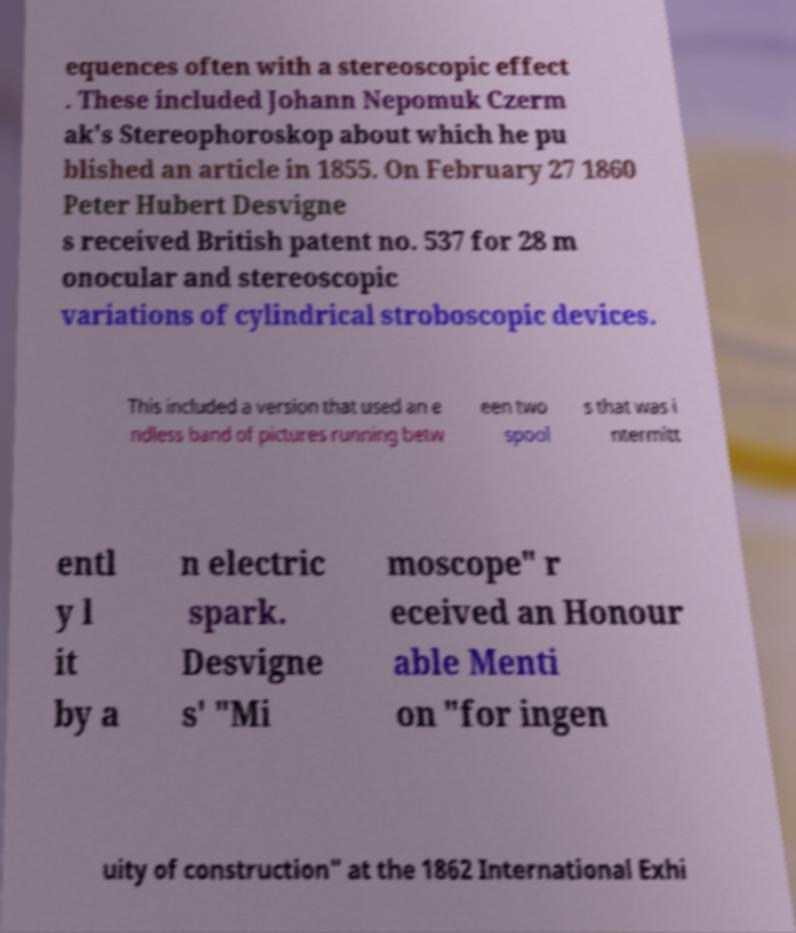There's text embedded in this image that I need extracted. Can you transcribe it verbatim? equences often with a stereoscopic effect . These included Johann Nepomuk Czerm ak's Stereophoroskop about which he pu blished an article in 1855. On February 27 1860 Peter Hubert Desvigne s received British patent no. 537 for 28 m onocular and stereoscopic variations of cylindrical stroboscopic devices. This included a version that used an e ndless band of pictures running betw een two spool s that was i ntermitt entl y l it by a n electric spark. Desvigne s' "Mi moscope" r eceived an Honour able Menti on "for ingen uity of construction" at the 1862 International Exhi 